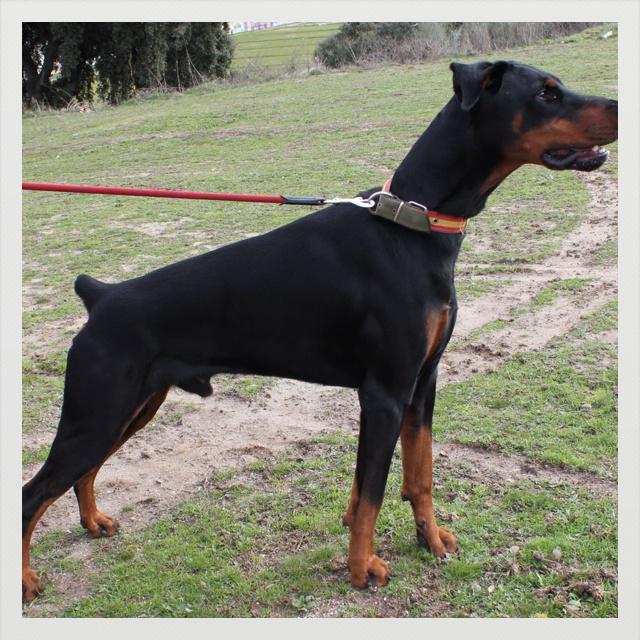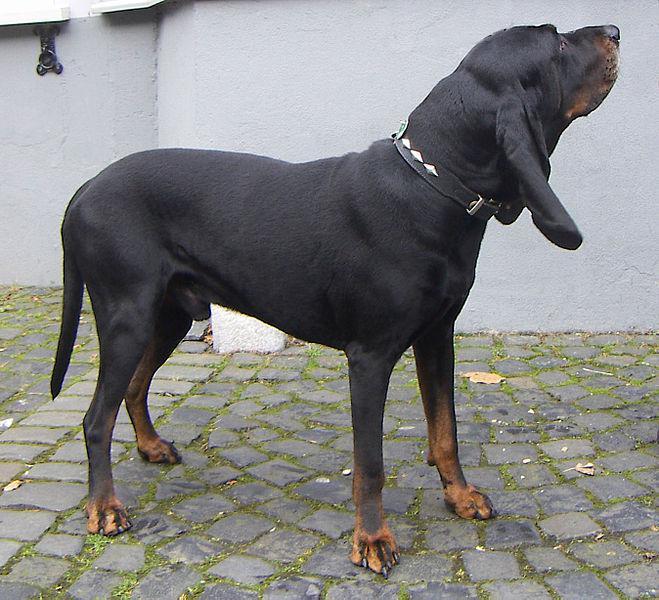The first image is the image on the left, the second image is the image on the right. Examine the images to the left and right. Is the description "The two dogs' bodies are pointed in opposite directions." accurate? Answer yes or no. No. The first image is the image on the left, the second image is the image on the right. Assess this claim about the two images: "Each image features a doberman with erect, upright ears, one of the dobermans depicted has an open mouth, and no doberman has a long tail.". Correct or not? Answer yes or no. No. 